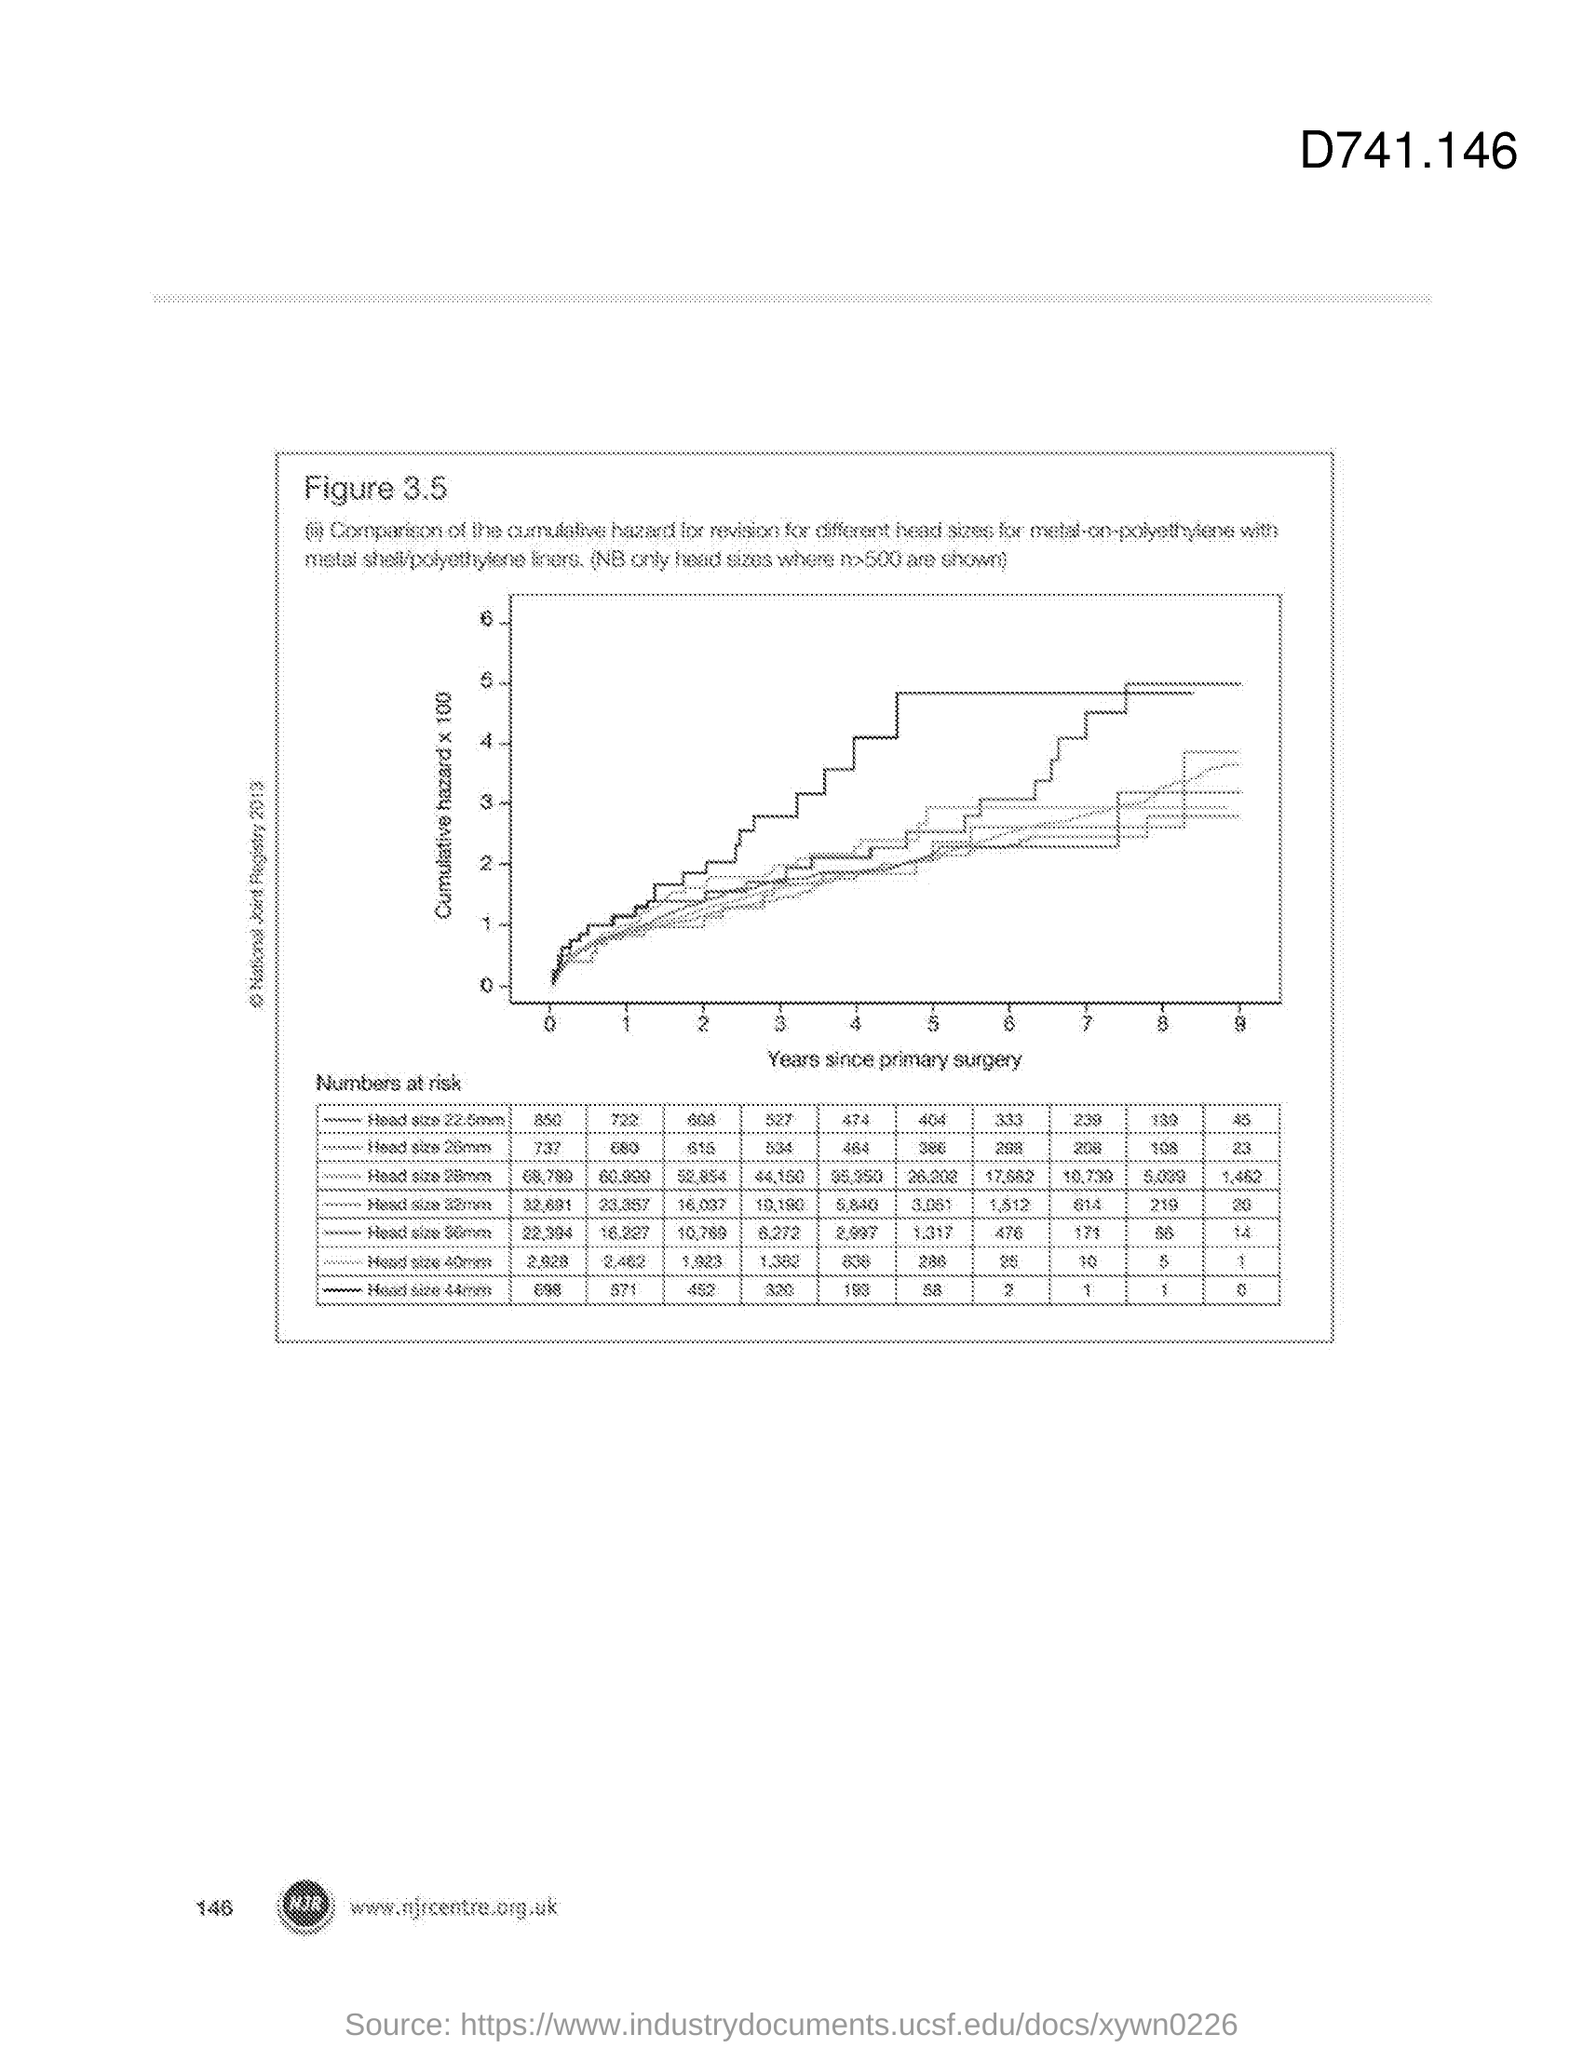What is plotted in the x-axis?
Make the answer very short. Years since primary surgery. What is plotted in the y-axis?
Offer a terse response. Cumulative hazard X 100. 